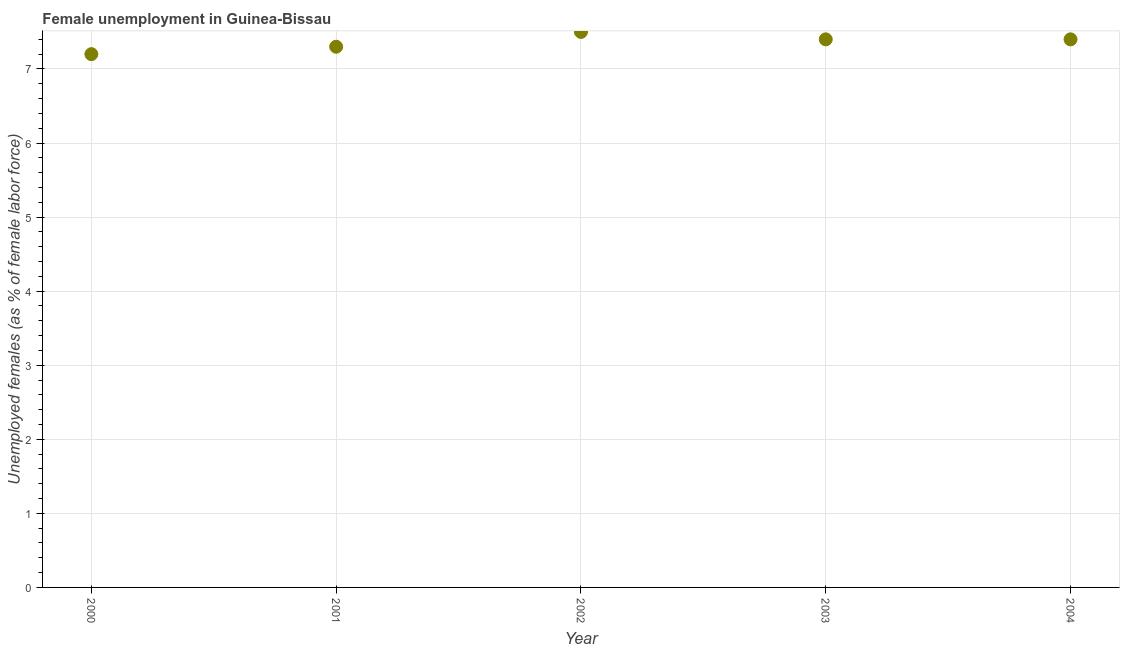What is the unemployed females population in 2001?
Provide a succinct answer. 7.3. Across all years, what is the minimum unemployed females population?
Offer a very short reply. 7.2. What is the sum of the unemployed females population?
Your answer should be very brief. 36.8. What is the difference between the unemployed females population in 2000 and 2004?
Offer a very short reply. -0.2. What is the average unemployed females population per year?
Provide a short and direct response. 7.36. What is the median unemployed females population?
Give a very brief answer. 7.4. In how many years, is the unemployed females population greater than 3.6 %?
Your response must be concise. 5. What is the ratio of the unemployed females population in 2002 to that in 2004?
Keep it short and to the point. 1.01. Is the unemployed females population in 2001 less than that in 2003?
Your response must be concise. Yes. Is the difference between the unemployed females population in 2001 and 2002 greater than the difference between any two years?
Keep it short and to the point. No. What is the difference between the highest and the second highest unemployed females population?
Provide a short and direct response. 0.1. What is the difference between the highest and the lowest unemployed females population?
Your response must be concise. 0.3. How many dotlines are there?
Provide a short and direct response. 1. How many years are there in the graph?
Ensure brevity in your answer.  5. What is the difference between two consecutive major ticks on the Y-axis?
Keep it short and to the point. 1. Does the graph contain any zero values?
Provide a succinct answer. No. What is the title of the graph?
Offer a very short reply. Female unemployment in Guinea-Bissau. What is the label or title of the X-axis?
Ensure brevity in your answer.  Year. What is the label or title of the Y-axis?
Provide a succinct answer. Unemployed females (as % of female labor force). What is the Unemployed females (as % of female labor force) in 2000?
Your answer should be compact. 7.2. What is the Unemployed females (as % of female labor force) in 2001?
Provide a short and direct response. 7.3. What is the Unemployed females (as % of female labor force) in 2002?
Provide a short and direct response. 7.5. What is the Unemployed females (as % of female labor force) in 2003?
Provide a short and direct response. 7.4. What is the Unemployed females (as % of female labor force) in 2004?
Ensure brevity in your answer.  7.4. What is the difference between the Unemployed females (as % of female labor force) in 2000 and 2002?
Provide a succinct answer. -0.3. What is the difference between the Unemployed females (as % of female labor force) in 2000 and 2003?
Offer a very short reply. -0.2. What is the difference between the Unemployed females (as % of female labor force) in 2001 and 2003?
Your response must be concise. -0.1. What is the difference between the Unemployed females (as % of female labor force) in 2003 and 2004?
Provide a short and direct response. 0. What is the ratio of the Unemployed females (as % of female labor force) in 2000 to that in 2003?
Make the answer very short. 0.97. What is the ratio of the Unemployed females (as % of female labor force) in 2002 to that in 2003?
Offer a terse response. 1.01. 